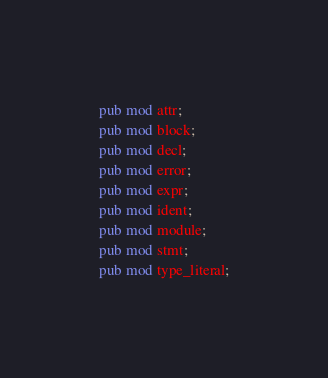<code> <loc_0><loc_0><loc_500><loc_500><_Rust_>pub mod attr;
pub mod block;
pub mod decl;
pub mod error;
pub mod expr;
pub mod ident;
pub mod module;
pub mod stmt;
pub mod type_literal;
</code> 